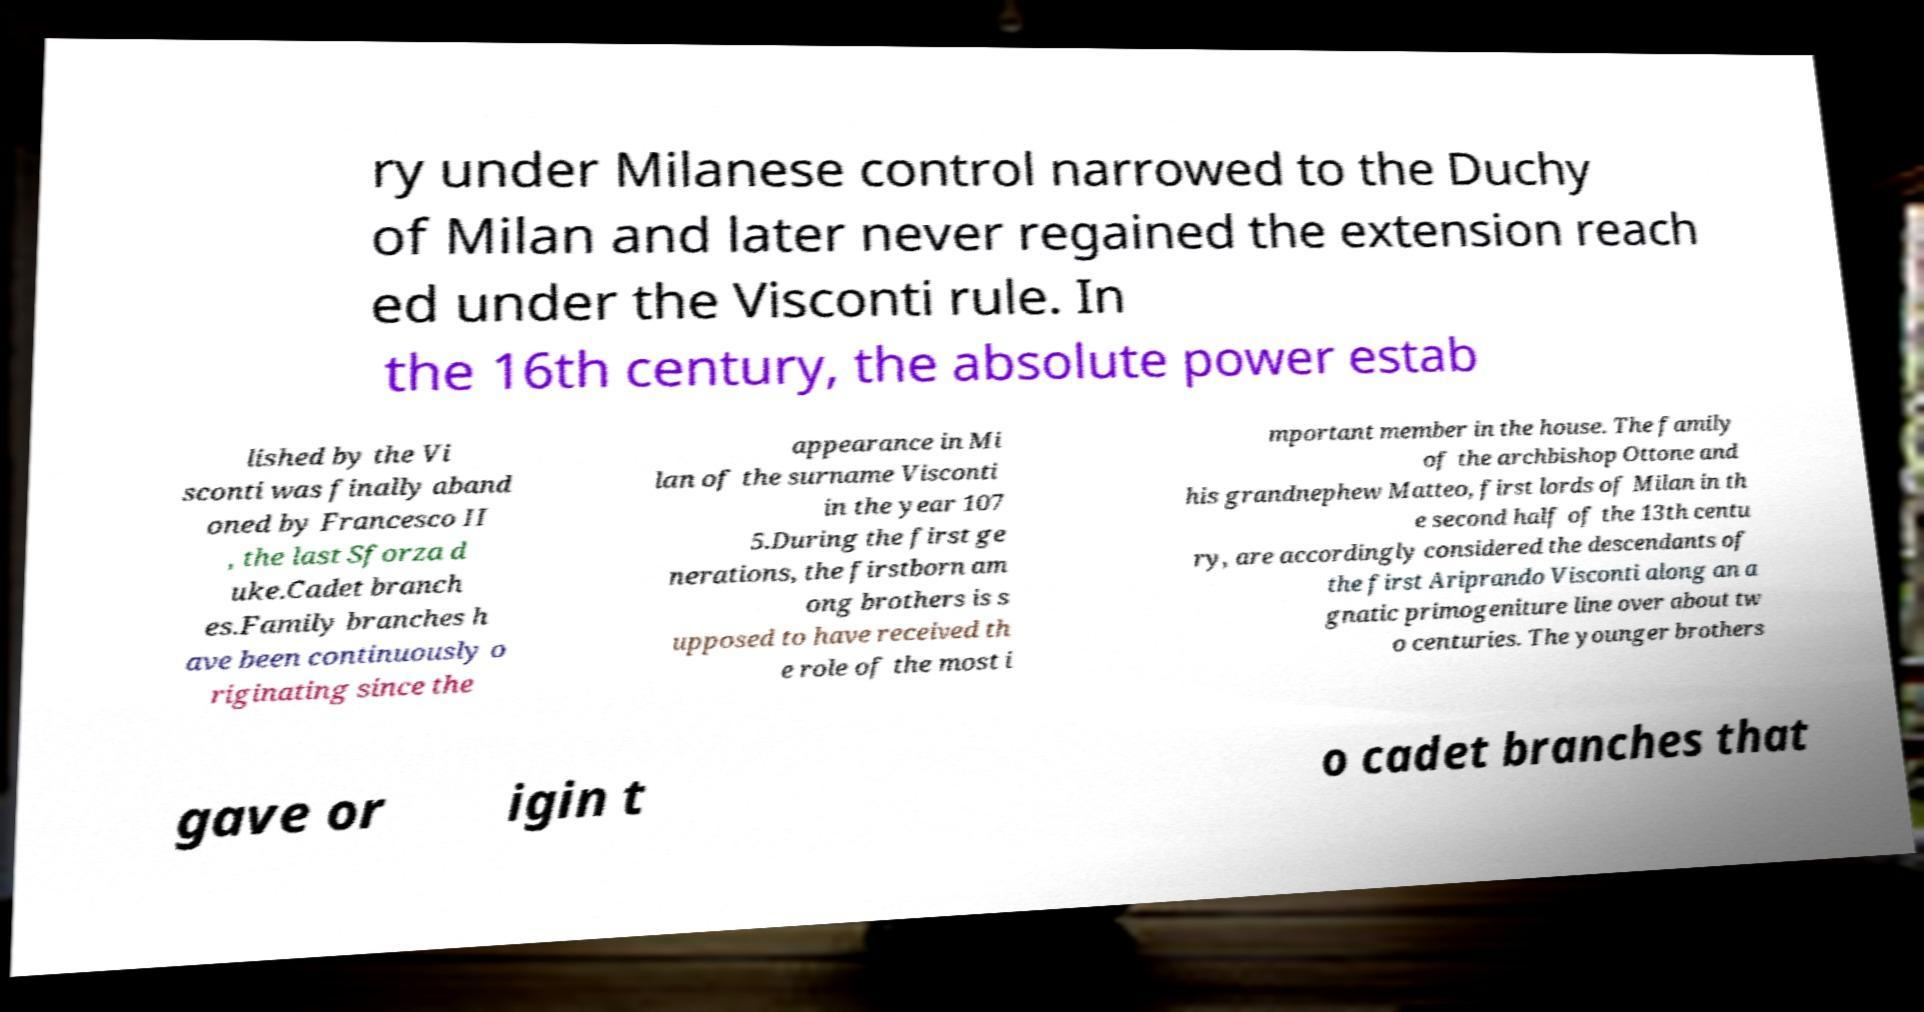What messages or text are displayed in this image? I need them in a readable, typed format. ry under Milanese control narrowed to the Duchy of Milan and later never regained the extension reach ed under the Visconti rule. In the 16th century, the absolute power estab lished by the Vi sconti was finally aband oned by Francesco II , the last Sforza d uke.Cadet branch es.Family branches h ave been continuously o riginating since the appearance in Mi lan of the surname Visconti in the year 107 5.During the first ge nerations, the firstborn am ong brothers is s upposed to have received th e role of the most i mportant member in the house. The family of the archbishop Ottone and his grandnephew Matteo, first lords of Milan in th e second half of the 13th centu ry, are accordingly considered the descendants of the first Ariprando Visconti along an a gnatic primogeniture line over about tw o centuries. The younger brothers gave or igin t o cadet branches that 